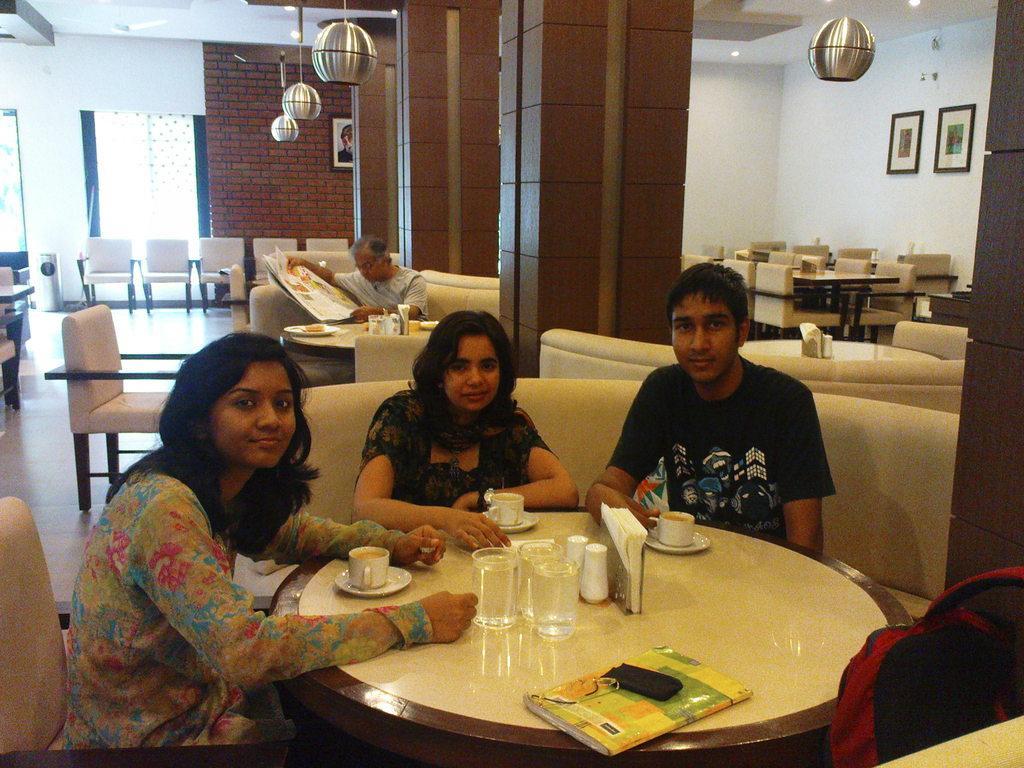Could you give a brief overview of what you see in this image? In this image there are 2 woman and a man sitting in the couch near the table , and in table there is book , glass, tissue paper , saucer , cup and in back ground there are lanterns , frame attached to a wall , chairs , another man reading the newspaper and a window. 